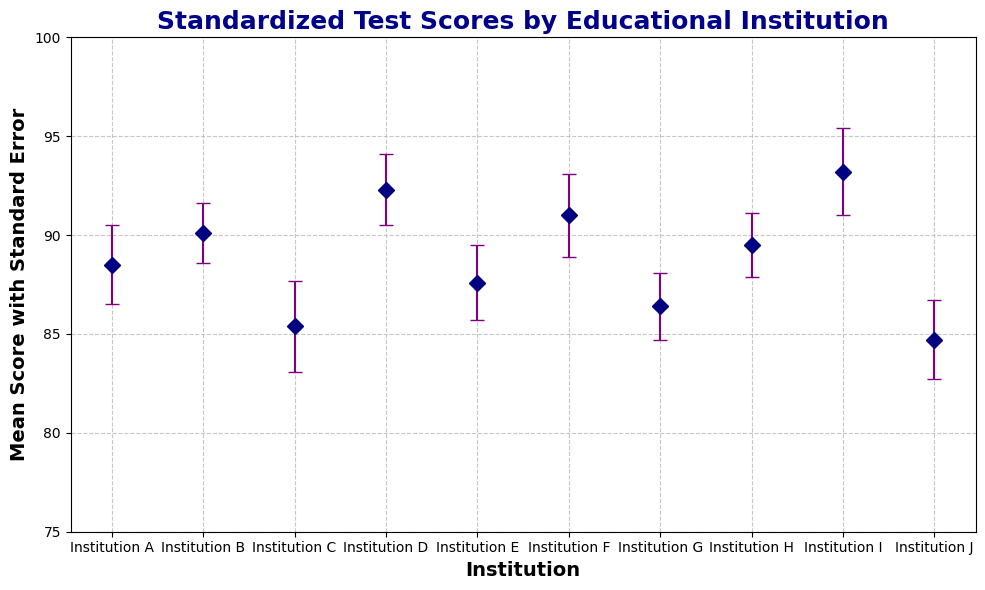What's the highest mean score among the institutions? To find the highest mean score, compare the mean scores of all institutions and identify the maximum value. Institution I has the highest mean score of 93.2.
Answer: 93.2 Which institution has the smallest standard error? To determine this, compare the standard errors of all institutions and identify the smallest value. Institution B has the smallest standard error of 1.5.
Answer: Institution B What's the difference in mean scores between the institution with the highest mean score and the institution with the lowest mean score? Find the mean scores of the institutions with the highest and lowest values which are Institution I (93.2) and Institution J (84.7) respectively. Subtract the lowest mean score from the highest mean score: 93.2 - 84.7 = 8.5.
Answer: 8.5 Which institutions have a mean score greater than 90? Check each institution's mean score to see if it is greater than 90. Institutions B, D, and I have mean scores of 90.1, 92.3, and 93.2 respectively, all greater than 90.
Answer: Institutions B, D, I What's the average mean score for all institutions combined? To find the average, sum all institutions' mean scores and divide by the number of institutions: (88.5 + 90.1 + 85.4 + 92.3 + 87.6 + 91.0 + 86.4 + 89.5 + 93.2 + 84.7)/10 = 88.87.
Answer: 88.87 Is there any institution with a mean score equal to the average mean score? From the previous calculation, the average mean score is 88.87. Compare this value with each institution's mean score. No institution has a mean score of exactly 88.87.
Answer: No How many institutions have a lower confidence interval above 85? Check if the lower confidence interval of each institution is above 85. Institutions B, D, F, and I have lower confidence intervals of 87.2, 88.8, 86.8, and 88.9 respectively, all above 85.
Answer: 4 Which institution has the broadest confidence interval range? Calculate the confidence interval range for each institution by subtracting the lower CI from the upper CI and identify the largest value. Institution I has the broadest range: 97.5 - 88.9 = 8.6.
Answer: Institution I Do any institutions have overlapping confidence intervals with Institution D? To check for overlapping intervals with Institution D (88.8 to 95.8), compare its intervals with others. Institutions B, F, H, and I overlap with Institution D as their intervals intersect or share values with Institution D's intervals.
Answer: Yes Which institutions have a mean score within one standard error of 90? For a mean score within 89 to 91 (since 90 ± 1 standard error), find institutions with mean scores in this range. Institutions B, H, and F have mean scores of 90.1, 89.5, and 91.0 respectively.
Answer: Institutions B, H, F 